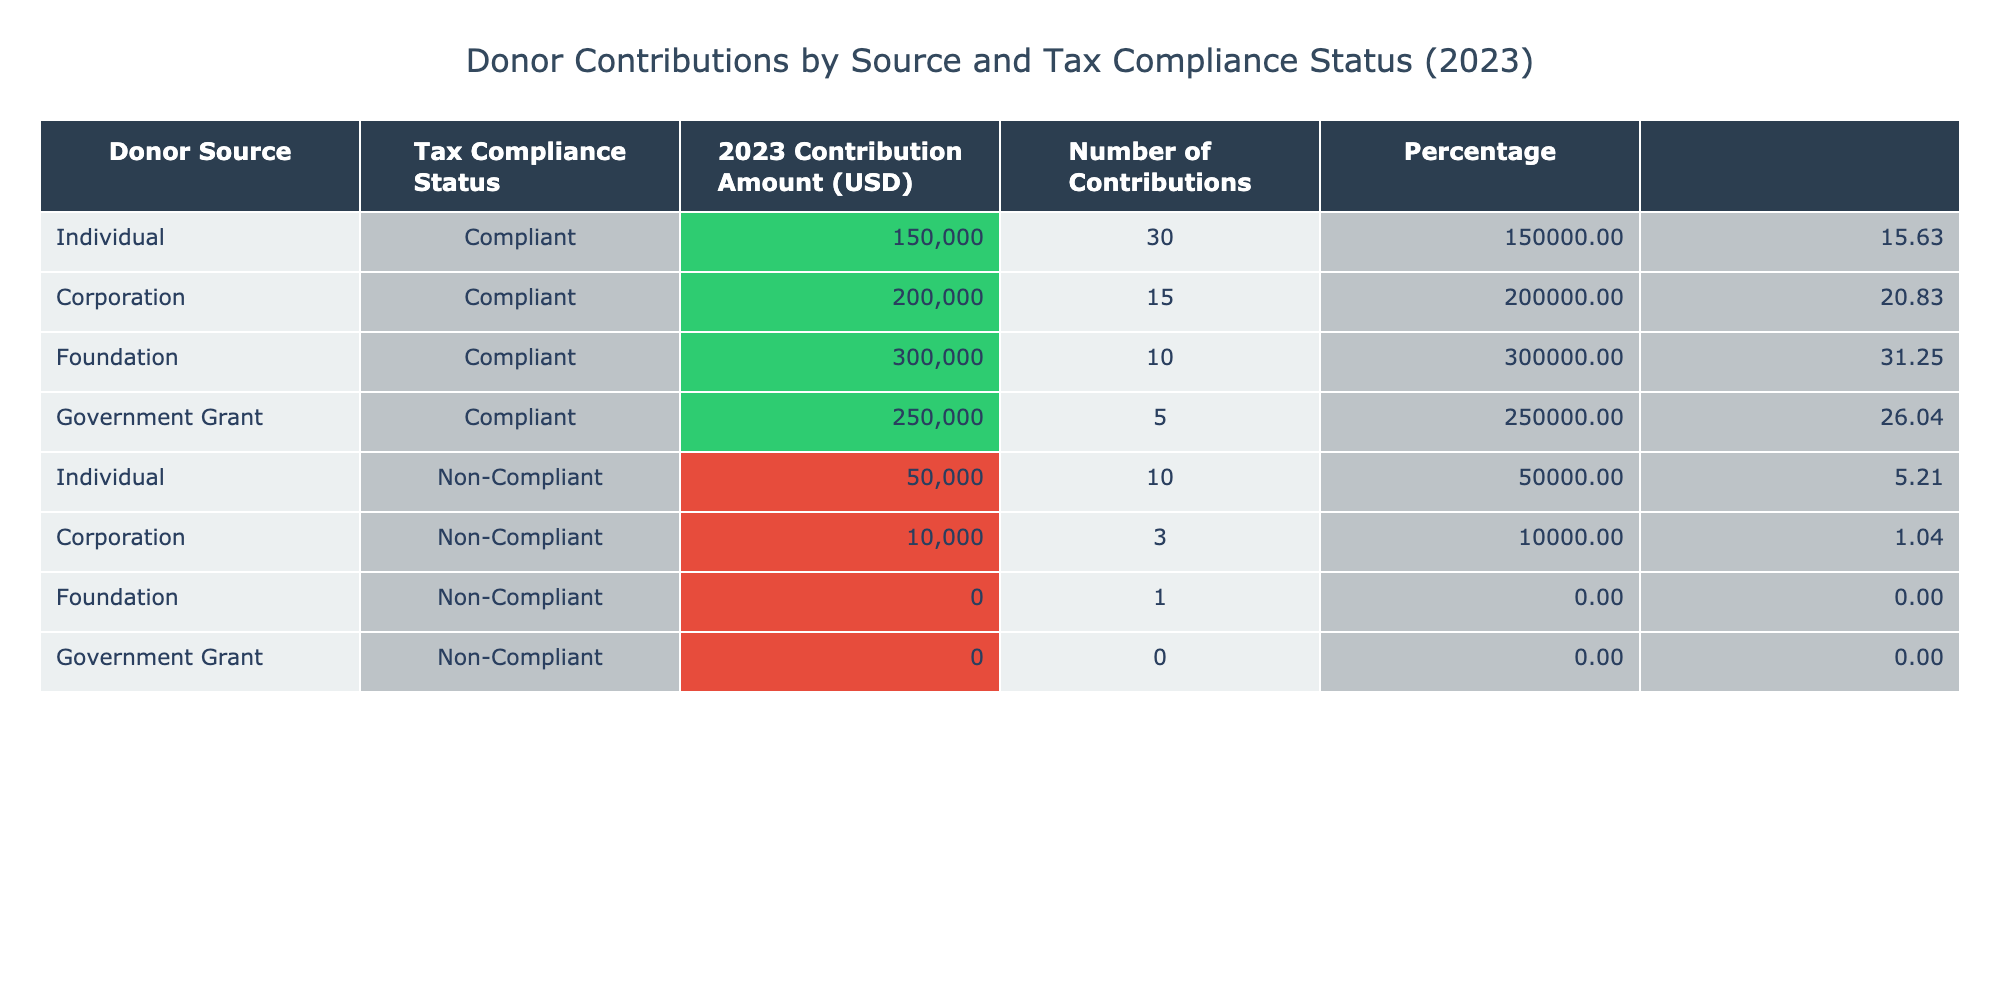What was the total contribution amount from compliant donors? To find the total contribution from compliant donors, sum the contribution amounts for the rows where the Tax Compliance Status is "Compliant." This includes: Individual (150000) + Corporation (200000) + Foundation (300000) + Government Grant (250000) = 900000.
Answer: 900000 How many contributions did non-compliant foundations make? There is one row for foundations with a tax compliance status of "Non-Compliant," which shows that there was 1 contribution.
Answer: 1 What is the total contribution amount from non-compliant sources? To calculate the total from non-compliant sources, sum the contribution amounts for the rows where Tax Compliance Status is "Non-Compliant." This includes: Individual (50000) + Corporation (10000) + Foundation (0) + Government Grant (0) = 60000.
Answer: 60000 Is there any government grant contribution from non-compliant donors? Referring to the table, the contribution amount for government grants under the non-compliant status is listed as 0. Therefore, there are no contributions from non-compliant government grants.
Answer: No Which donor source had the highest contribution amount and what was that amount? Looking at the contribution amounts, the Foundation has the highest contribution of 300000.
Answer: Foundation, 300000 What is the average contribution amount for compliant individual donors? There are 30 individual contributions from compliant donors with a total contribution of 150000. Average = Total Contributions / Number of Contributions = 150000 / 30 = 5000.
Answer: 5000 What percentage of the total contributions came from non-compliant corporations? First, calculate the total contributions. It's 900000 (compliant) + 60000 (non-compliant) = 960000. For non-compliant corporations, the contribution is 10000. Percentage = (10000 / 960000) * 100 = 1.04%.
Answer: 1.04% How many total contributions are there from compliant and non-compliant sources combined? To get the total contributions, add the number of contributions for all rows. Compliant: 30 (Individual) + 15 (Corporation) + 10 (Foundation) + 5 (Government Grant) = 60. Non-Compliant: 10 (Individual) + 3 (Corporation) + 1 (Foundation) + 0 (Government Grant) = 14. Therefore, total = 60 + 14 = 74.
Answer: 74 What was the contribution amount from compliant corporations? From the table, the contribution amount from compliant corporations is clearly listed as 200000.
Answer: 200000 